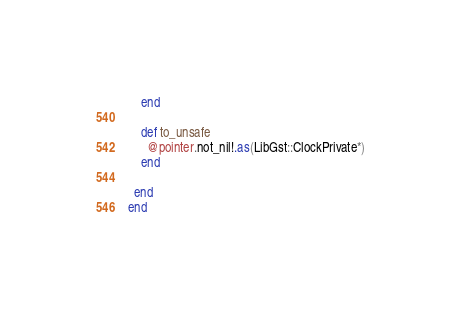Convert code to text. <code><loc_0><loc_0><loc_500><loc_500><_Crystal_>    end

    def to_unsafe
      @pointer.not_nil!.as(LibGst::ClockPrivate*)
    end

  end
end

</code> 